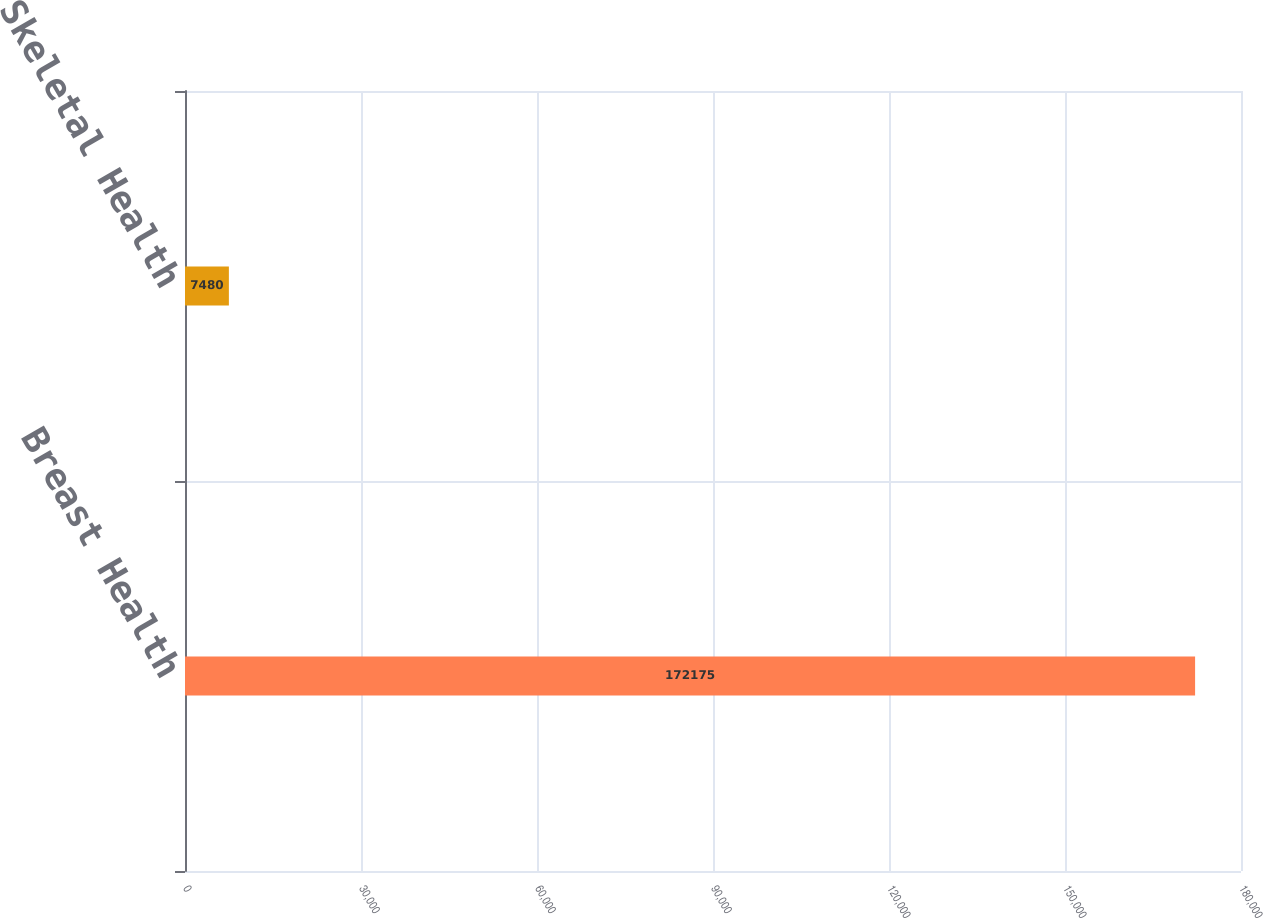<chart> <loc_0><loc_0><loc_500><loc_500><bar_chart><fcel>Breast Health<fcel>Skeletal Health<nl><fcel>172175<fcel>7480<nl></chart> 